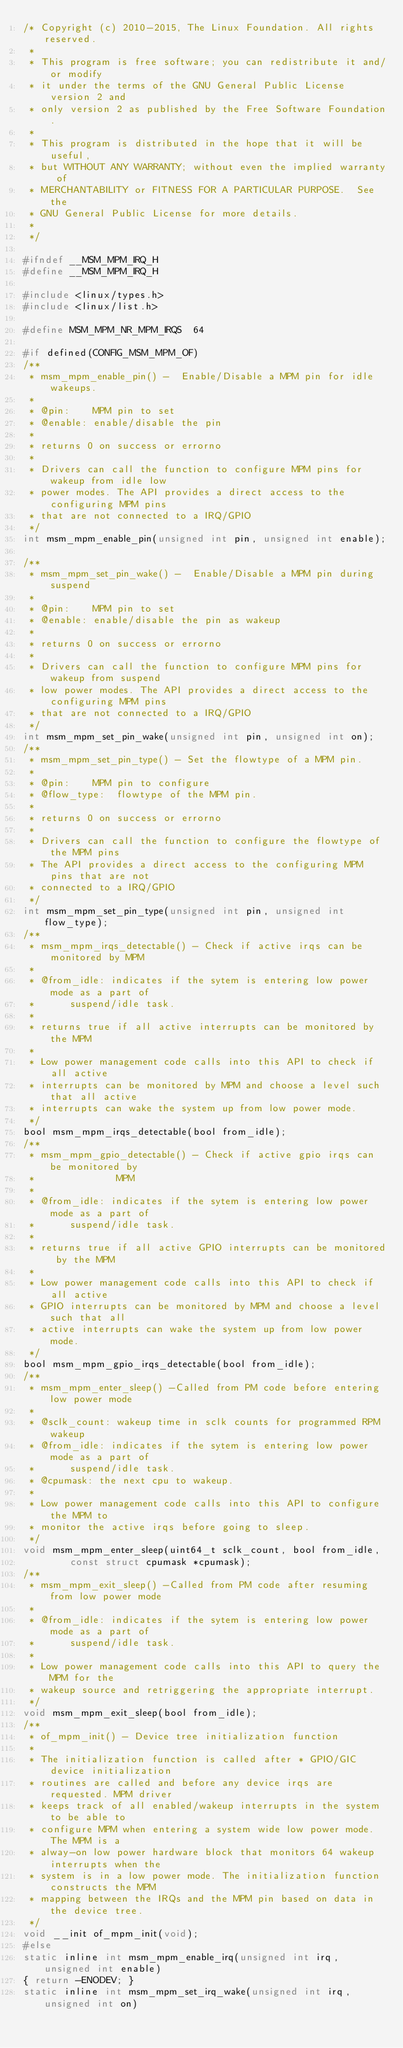<code> <loc_0><loc_0><loc_500><loc_500><_C_>/* Copyright (c) 2010-2015, The Linux Foundation. All rights reserved.
 *
 * This program is free software; you can redistribute it and/or modify
 * it under the terms of the GNU General Public License version 2 and
 * only version 2 as published by the Free Software Foundation.
 *
 * This program is distributed in the hope that it will be useful,
 * but WITHOUT ANY WARRANTY; without even the implied warranty of
 * MERCHANTABILITY or FITNESS FOR A PARTICULAR PURPOSE.  See the
 * GNU General Public License for more details.
 *
 */

#ifndef __MSM_MPM_IRQ_H
#define __MSM_MPM_IRQ_H

#include <linux/types.h>
#include <linux/list.h>

#define MSM_MPM_NR_MPM_IRQS  64

#if defined(CONFIG_MSM_MPM_OF)
/**
 * msm_mpm_enable_pin() -  Enable/Disable a MPM pin for idle wakeups.
 *
 * @pin:	MPM pin to set
 * @enable:	enable/disable the pin
 *
 * returns 0 on success or errorno
 *
 * Drivers can call the function to configure MPM pins for wakeup from idle low
 * power modes. The API provides a direct access to the configuring MPM pins
 * that are not connected to a IRQ/GPIO
 */
int msm_mpm_enable_pin(unsigned int pin, unsigned int enable);

/**
 * msm_mpm_set_pin_wake() -  Enable/Disable a MPM pin during suspend
 *
 * @pin:	MPM pin to set
 * @enable:	enable/disable the pin as wakeup
 *
 * returns 0 on success or errorno
 *
 * Drivers can call the function to configure MPM pins for wakeup from suspend
 * low power modes. The API provides a direct access to the configuring MPM pins
 * that are not connected to a IRQ/GPIO
 */
int msm_mpm_set_pin_wake(unsigned int pin, unsigned int on);
/**
 * msm_mpm_set_pin_type() - Set the flowtype of a MPM pin.
 *
 * @pin:	MPM pin to configure
 * @flow_type:	flowtype of the MPM pin.
 *
 * returns 0 on success or errorno
 *
 * Drivers can call the function to configure the flowtype of the MPM pins
 * The API provides a direct access to the configuring MPM pins that are not
 * connected to a IRQ/GPIO
 */
int msm_mpm_set_pin_type(unsigned int pin, unsigned int flow_type);
/**
 * msm_mpm_irqs_detectable() - Check if active irqs can be monitored by MPM
 *
 * @from_idle: indicates if the sytem is entering low power mode as a part of
 *		suspend/idle task.
 *
 * returns true if all active interrupts can be monitored by the MPM
 *
 * Low power management code calls into this API to check if all active
 * interrupts can be monitored by MPM and choose a level such that all active
 * interrupts can wake the system up from low power mode.
 */
bool msm_mpm_irqs_detectable(bool from_idle);
/**
 * msm_mpm_gpio_detectable() - Check if active gpio irqs can be monitored by
 *				MPM
 *
 * @from_idle: indicates if the sytem is entering low power mode as a part of
 *		suspend/idle task.
 *
 * returns true if all active GPIO interrupts can be monitored by the MPM
 *
 * Low power management code calls into this API to check if all active
 * GPIO interrupts can be monitored by MPM and choose a level such that all
 * active interrupts can wake the system up from low power mode.
 */
bool msm_mpm_gpio_irqs_detectable(bool from_idle);
/**
 * msm_mpm_enter_sleep() -Called from PM code before entering low power mode
 *
 * @sclk_count: wakeup time in sclk counts for programmed RPM wakeup
 * @from_idle: indicates if the sytem is entering low power mode as a part of
 *		suspend/idle task.
 * @cpumask: the next cpu to wakeup.
 *
 * Low power management code calls into this API to configure the MPM to
 * monitor the active irqs before going to sleep.
 */
void msm_mpm_enter_sleep(uint64_t sclk_count, bool from_idle,
		const struct cpumask *cpumask);
/**
 * msm_mpm_exit_sleep() -Called from PM code after resuming from low power mode
 *
 * @from_idle: indicates if the sytem is entering low power mode as a part of
 *		suspend/idle task.
 *
 * Low power management code calls into this API to query the MPM for the
 * wakeup source and retriggering the appropriate interrupt.
 */
void msm_mpm_exit_sleep(bool from_idle);
/**
 * of_mpm_init() - Device tree initialization function
 *
 * The initialization function is called after * GPIO/GIC device initialization
 * routines are called and before any device irqs are requested. MPM driver
 * keeps track of all enabled/wakeup interrupts in the system to be able to
 * configure MPM when entering a system wide low power mode. The MPM is a
 * alway-on low power hardware block that monitors 64 wakeup interrupts when the
 * system is in a low power mode. The initialization function constructs the MPM
 * mapping between the IRQs and the MPM pin based on data in the device tree.
 */
void __init of_mpm_init(void);
#else
static inline int msm_mpm_enable_irq(unsigned int irq, unsigned int enable)
{ return -ENODEV; }
static inline int msm_mpm_set_irq_wake(unsigned int irq, unsigned int on)</code> 